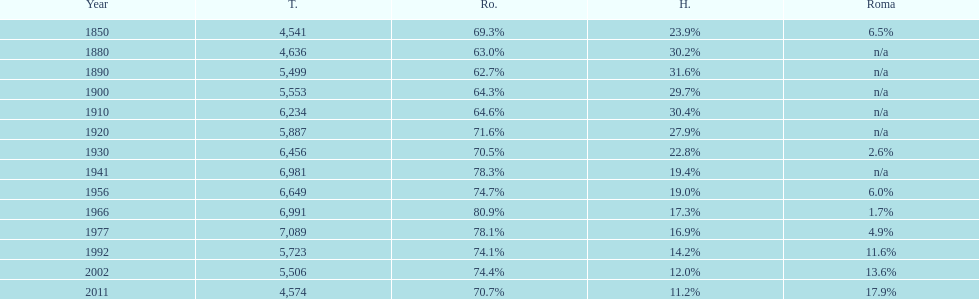What were the total number of times the romanians had a population percentage above 70%? 9. 